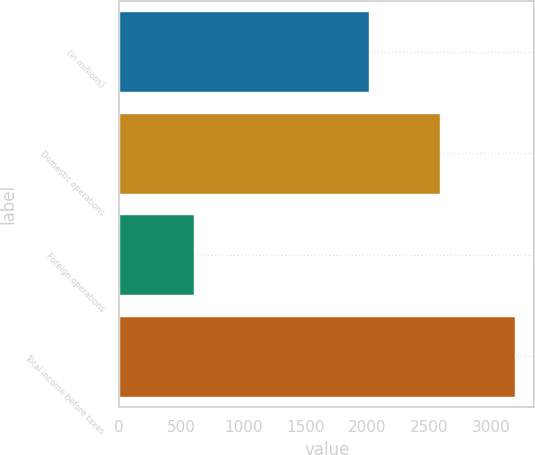Convert chart to OTSL. <chart><loc_0><loc_0><loc_500><loc_500><bar_chart><fcel>(in millions)<fcel>Domestic operations<fcel>Foreign operations<fcel>Total income before taxes<nl><fcel>2016<fcel>2585<fcel>603<fcel>3188<nl></chart> 